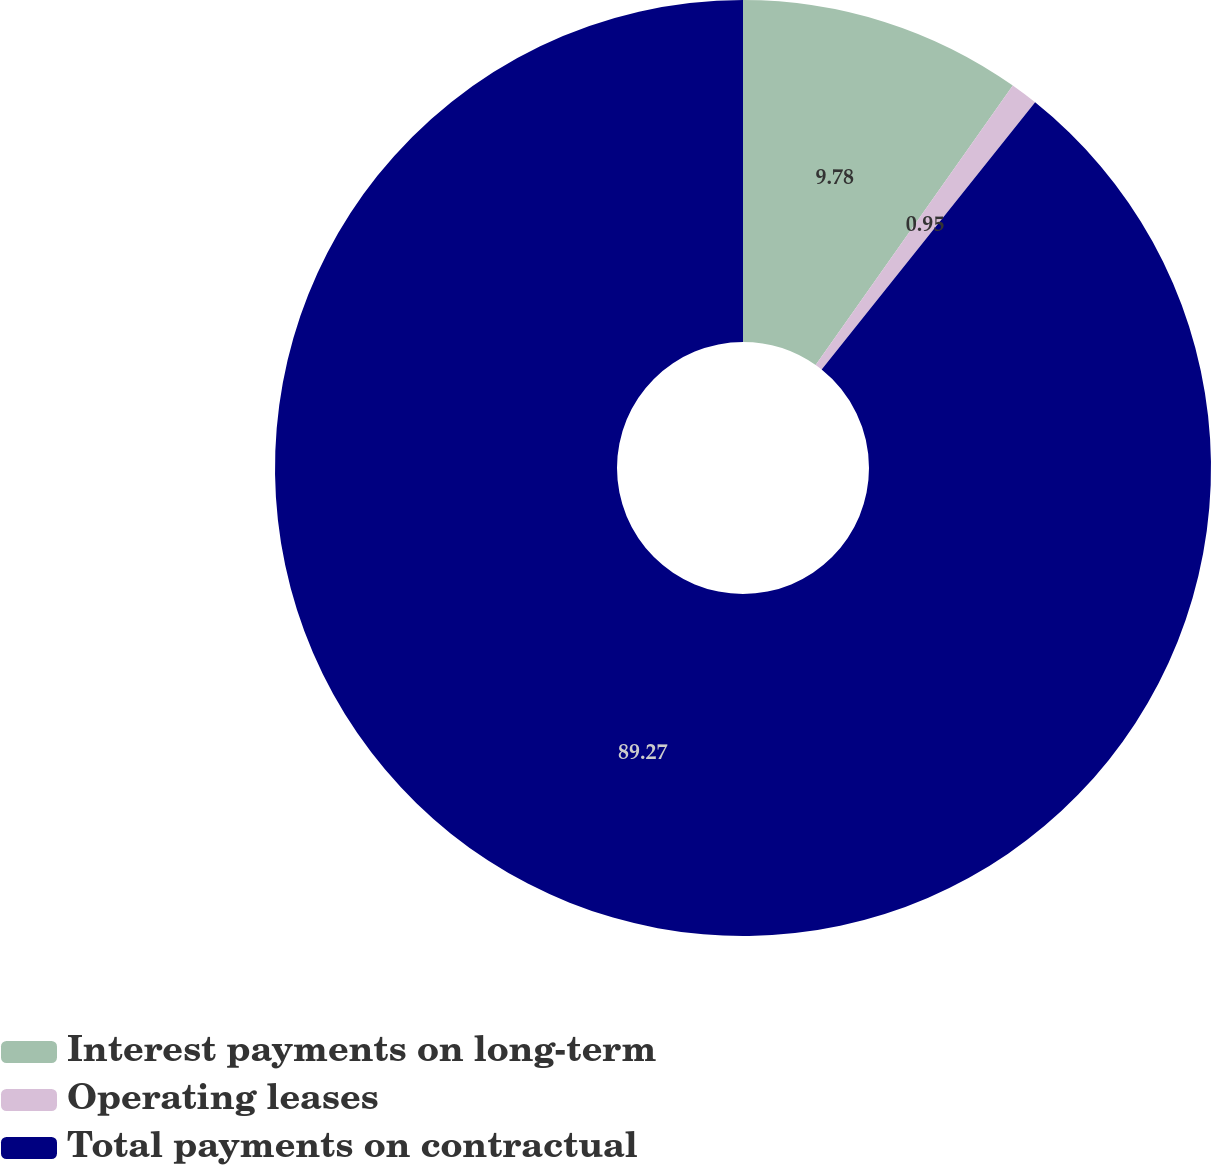<chart> <loc_0><loc_0><loc_500><loc_500><pie_chart><fcel>Interest payments on long-term<fcel>Operating leases<fcel>Total payments on contractual<nl><fcel>9.78%<fcel>0.95%<fcel>89.28%<nl></chart> 